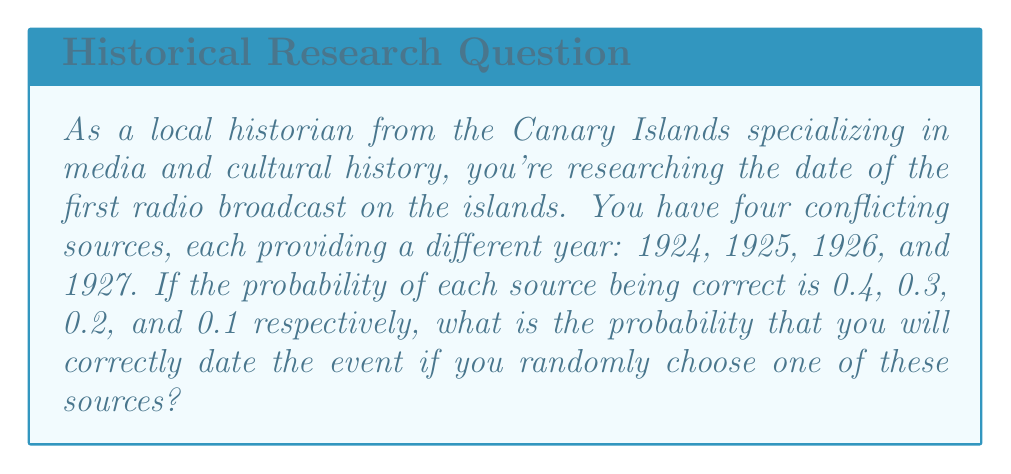Can you answer this question? To solve this problem, we need to understand that the probability of correctly dating the event is equal to the probability of choosing the correct source. Let's break it down step-by-step:

1) We have four sources, each with a different probability of being correct:
   Source 1 (1924): $P(S_1) = 0.4$
   Source 2 (1925): $P(S_2) = 0.3$
   Source 3 (1926): $P(S_3) = 0.2$
   Source 4 (1927): $P(S_4) = 0.1$

2) The probability of correctly dating the event is the sum of the probabilities of choosing each correct source. Since we're randomly choosing one source, the probability of choosing any particular source is equal (1/4 for each).

3) We can express this mathematically as:

   $$P(\text{correct date}) = P(S_1) \cdot \frac{1}{4} + P(S_2) \cdot \frac{1}{4} + P(S_3) \cdot \frac{1}{4} + P(S_4) \cdot \frac{1}{4}$$

4) Now, let's substitute the values:

   $$P(\text{correct date}) = 0.4 \cdot \frac{1}{4} + 0.3 \cdot \frac{1}{4} + 0.2 \cdot \frac{1}{4} + 0.1 \cdot \frac{1}{4}$$

5) Simplify:

   $$P(\text{correct date}) = \frac{0.4 + 0.3 + 0.2 + 0.1}{4} = \frac{1}{4} = 0.25$$

Therefore, the probability of correctly dating the event by randomly choosing one of these sources is 0.25 or 25%.
Answer: 0.25 